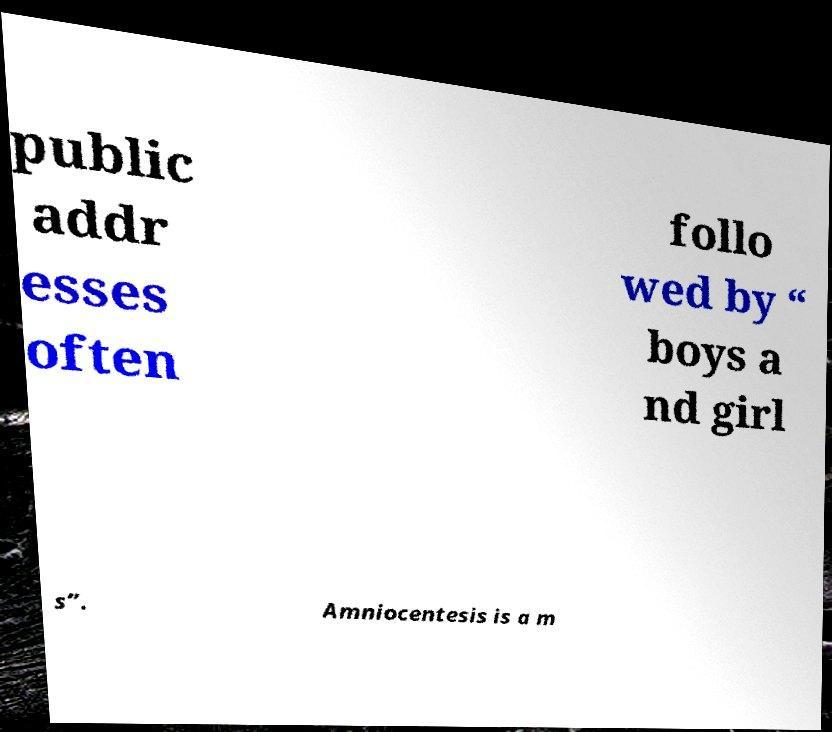What messages or text are displayed in this image? I need them in a readable, typed format. public addr esses often follo wed by “ boys a nd girl s”. Amniocentesis is a m 